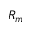Convert formula to latex. <formula><loc_0><loc_0><loc_500><loc_500>R _ { m }</formula> 